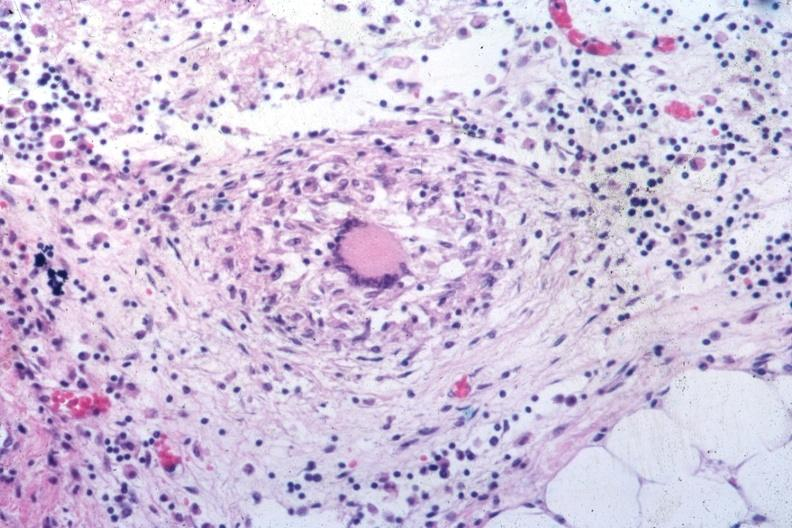s peritoneal fluid present?
Answer the question using a single word or phrase. No 